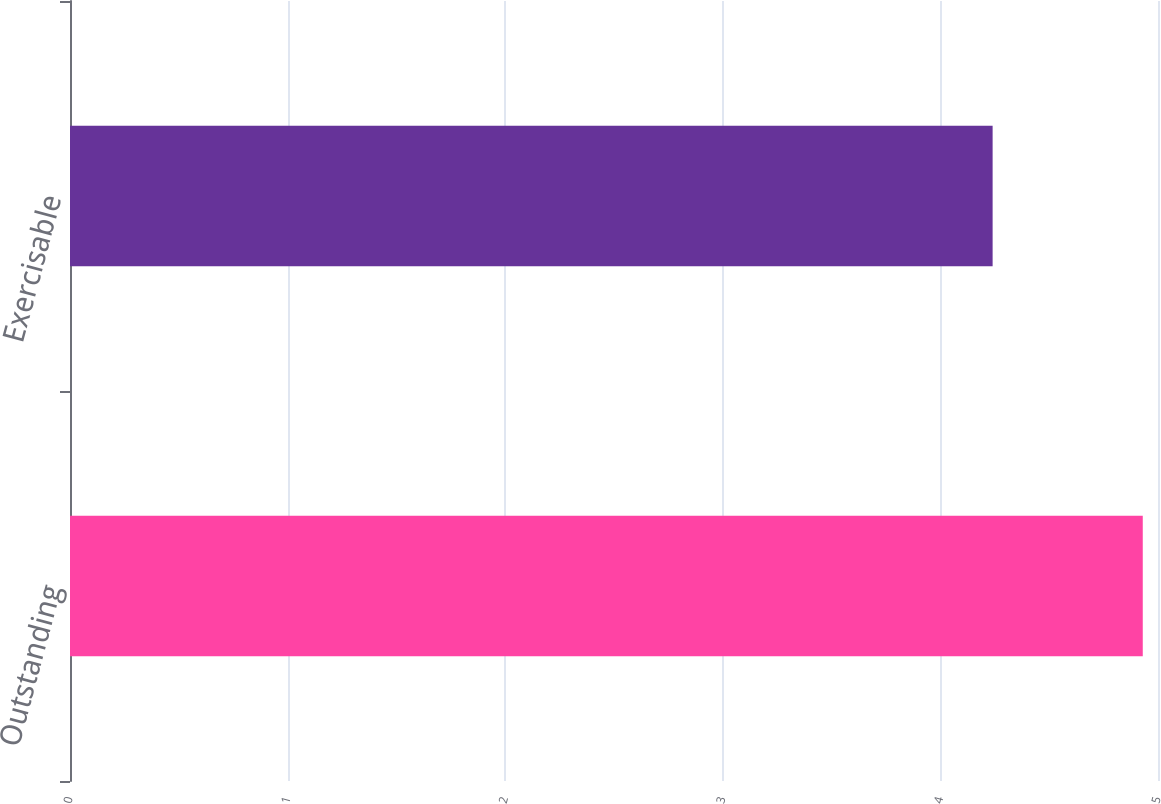<chart> <loc_0><loc_0><loc_500><loc_500><bar_chart><fcel>Outstanding<fcel>Exercisable<nl><fcel>4.93<fcel>4.24<nl></chart> 